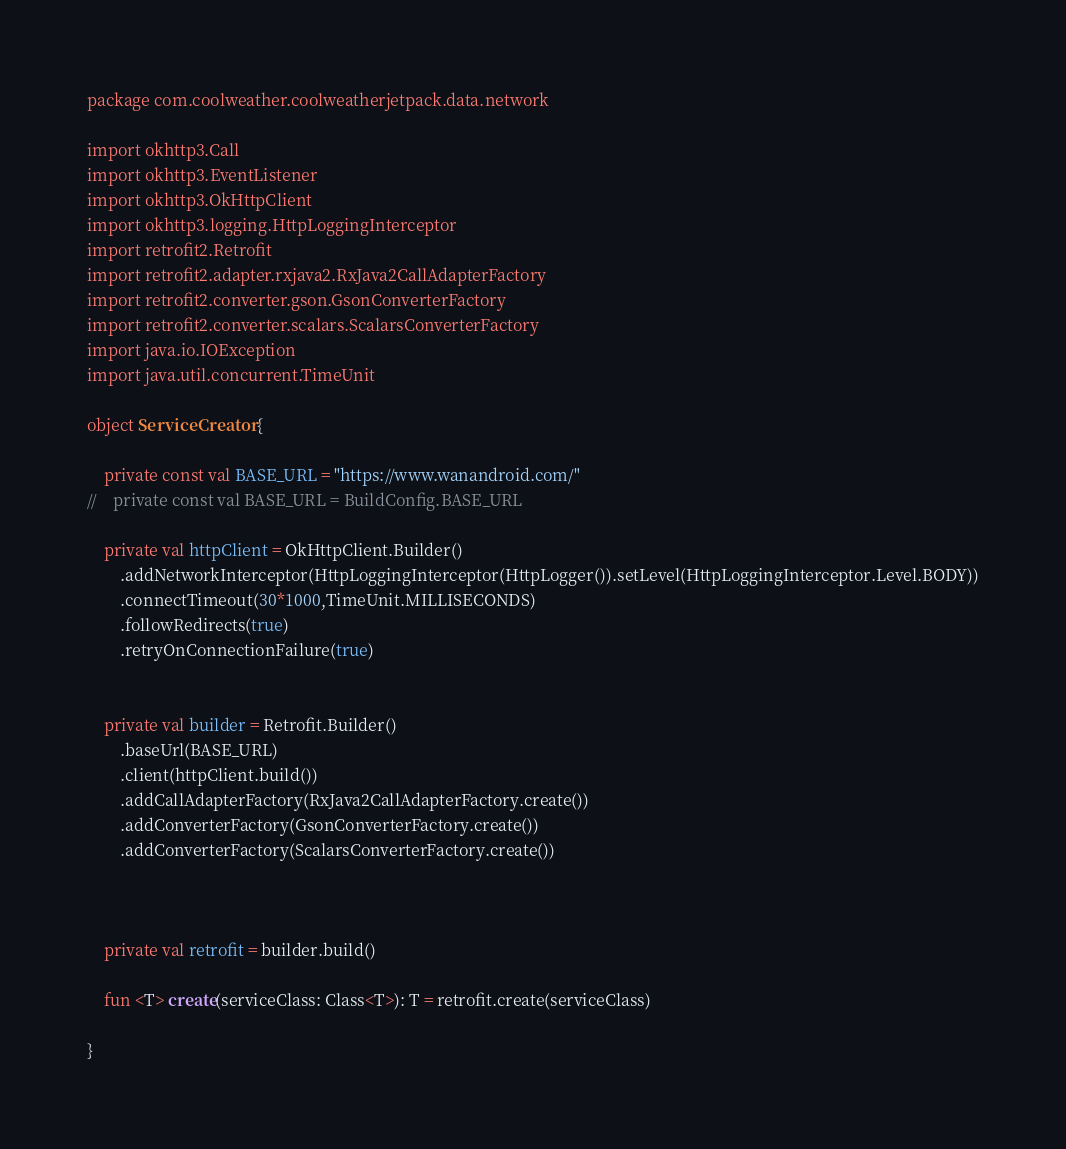<code> <loc_0><loc_0><loc_500><loc_500><_Kotlin_>package com.coolweather.coolweatherjetpack.data.network

import okhttp3.Call
import okhttp3.EventListener
import okhttp3.OkHttpClient
import okhttp3.logging.HttpLoggingInterceptor
import retrofit2.Retrofit
import retrofit2.adapter.rxjava2.RxJava2CallAdapterFactory
import retrofit2.converter.gson.GsonConverterFactory
import retrofit2.converter.scalars.ScalarsConverterFactory
import java.io.IOException
import java.util.concurrent.TimeUnit

object ServiceCreator {

    private const val BASE_URL = "https://www.wanandroid.com/"
//    private const val BASE_URL = BuildConfig.BASE_URL

    private val httpClient = OkHttpClient.Builder()
        .addNetworkInterceptor(HttpLoggingInterceptor(HttpLogger()).setLevel(HttpLoggingInterceptor.Level.BODY))
        .connectTimeout(30*1000,TimeUnit.MILLISECONDS)
        .followRedirects(true)
        .retryOnConnectionFailure(true)


    private val builder = Retrofit.Builder()
        .baseUrl(BASE_URL)
        .client(httpClient.build())
        .addCallAdapterFactory(RxJava2CallAdapterFactory.create())
        .addConverterFactory(GsonConverterFactory.create())
        .addConverterFactory(ScalarsConverterFactory.create())



    private val retrofit = builder.build()

    fun <T> create(serviceClass: Class<T>): T = retrofit.create(serviceClass)

}</code> 